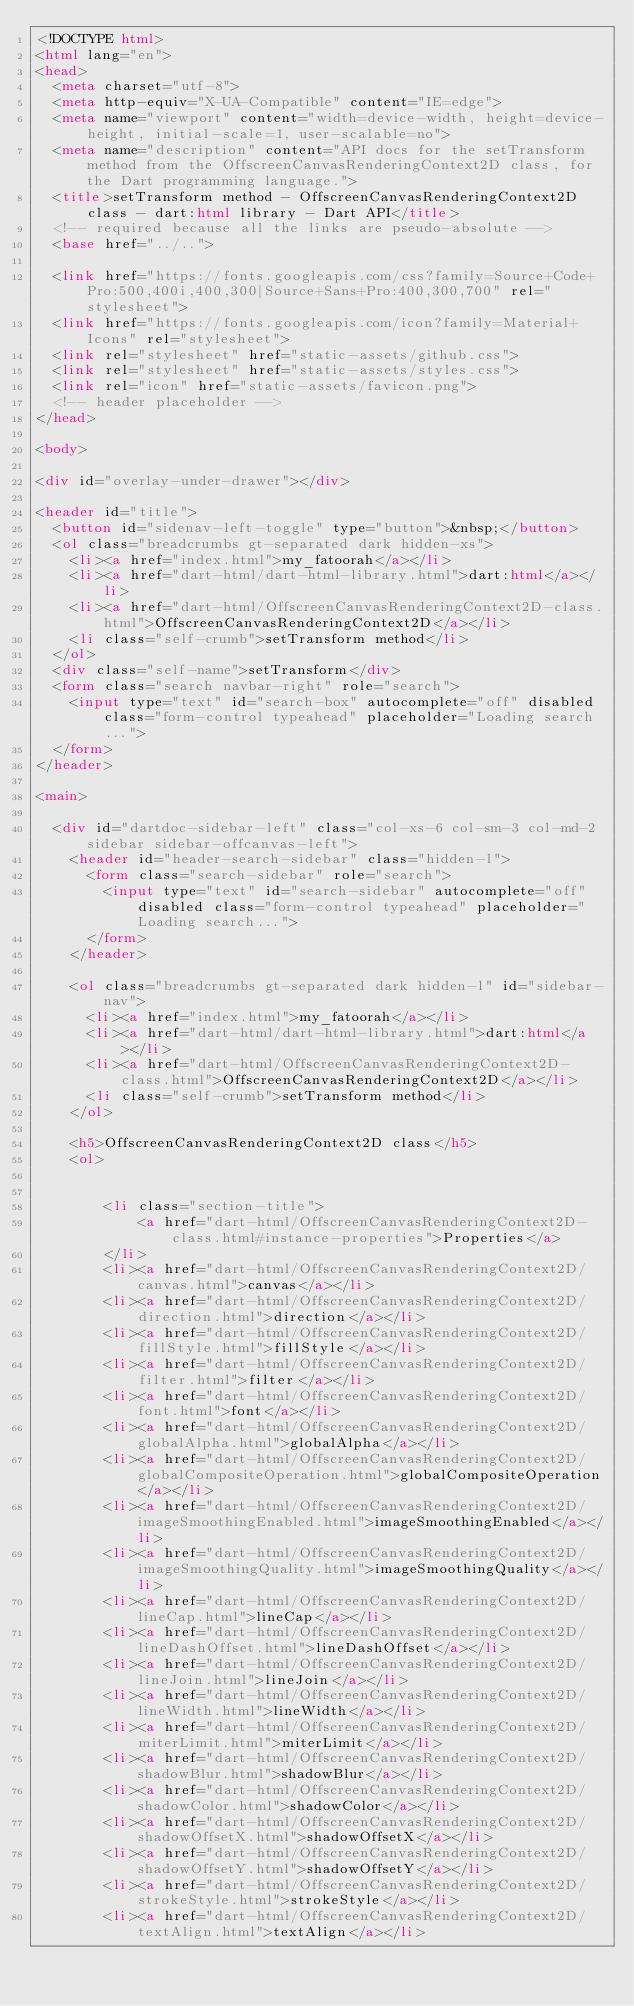Convert code to text. <code><loc_0><loc_0><loc_500><loc_500><_HTML_><!DOCTYPE html>
<html lang="en">
<head>
  <meta charset="utf-8">
  <meta http-equiv="X-UA-Compatible" content="IE=edge">
  <meta name="viewport" content="width=device-width, height=device-height, initial-scale=1, user-scalable=no">
  <meta name="description" content="API docs for the setTransform method from the OffscreenCanvasRenderingContext2D class, for the Dart programming language.">
  <title>setTransform method - OffscreenCanvasRenderingContext2D class - dart:html library - Dart API</title>
  <!-- required because all the links are pseudo-absolute -->
  <base href="../..">

  <link href="https://fonts.googleapis.com/css?family=Source+Code+Pro:500,400i,400,300|Source+Sans+Pro:400,300,700" rel="stylesheet">
  <link href="https://fonts.googleapis.com/icon?family=Material+Icons" rel="stylesheet">
  <link rel="stylesheet" href="static-assets/github.css">
  <link rel="stylesheet" href="static-assets/styles.css">
  <link rel="icon" href="static-assets/favicon.png">
  <!-- header placeholder -->
</head>

<body>

<div id="overlay-under-drawer"></div>

<header id="title">
  <button id="sidenav-left-toggle" type="button">&nbsp;</button>
  <ol class="breadcrumbs gt-separated dark hidden-xs">
    <li><a href="index.html">my_fatoorah</a></li>
    <li><a href="dart-html/dart-html-library.html">dart:html</a></li>
    <li><a href="dart-html/OffscreenCanvasRenderingContext2D-class.html">OffscreenCanvasRenderingContext2D</a></li>
    <li class="self-crumb">setTransform method</li>
  </ol>
  <div class="self-name">setTransform</div>
  <form class="search navbar-right" role="search">
    <input type="text" id="search-box" autocomplete="off" disabled class="form-control typeahead" placeholder="Loading search...">
  </form>
</header>

<main>

  <div id="dartdoc-sidebar-left" class="col-xs-6 col-sm-3 col-md-2 sidebar sidebar-offcanvas-left">
    <header id="header-search-sidebar" class="hidden-l">
      <form class="search-sidebar" role="search">
        <input type="text" id="search-sidebar" autocomplete="off" disabled class="form-control typeahead" placeholder="Loading search...">
      </form>
    </header>
    
    <ol class="breadcrumbs gt-separated dark hidden-l" id="sidebar-nav">
      <li><a href="index.html">my_fatoorah</a></li>
      <li><a href="dart-html/dart-html-library.html">dart:html</a></li>
      <li><a href="dart-html/OffscreenCanvasRenderingContext2D-class.html">OffscreenCanvasRenderingContext2D</a></li>
      <li class="self-crumb">setTransform method</li>
    </ol>
    
    <h5>OffscreenCanvasRenderingContext2D class</h5>
    <ol>
    
    
        <li class="section-title">
            <a href="dart-html/OffscreenCanvasRenderingContext2D-class.html#instance-properties">Properties</a>
        </li>
        <li><a href="dart-html/OffscreenCanvasRenderingContext2D/canvas.html">canvas</a></li>
        <li><a href="dart-html/OffscreenCanvasRenderingContext2D/direction.html">direction</a></li>
        <li><a href="dart-html/OffscreenCanvasRenderingContext2D/fillStyle.html">fillStyle</a></li>
        <li><a href="dart-html/OffscreenCanvasRenderingContext2D/filter.html">filter</a></li>
        <li><a href="dart-html/OffscreenCanvasRenderingContext2D/font.html">font</a></li>
        <li><a href="dart-html/OffscreenCanvasRenderingContext2D/globalAlpha.html">globalAlpha</a></li>
        <li><a href="dart-html/OffscreenCanvasRenderingContext2D/globalCompositeOperation.html">globalCompositeOperation</a></li>
        <li><a href="dart-html/OffscreenCanvasRenderingContext2D/imageSmoothingEnabled.html">imageSmoothingEnabled</a></li>
        <li><a href="dart-html/OffscreenCanvasRenderingContext2D/imageSmoothingQuality.html">imageSmoothingQuality</a></li>
        <li><a href="dart-html/OffscreenCanvasRenderingContext2D/lineCap.html">lineCap</a></li>
        <li><a href="dart-html/OffscreenCanvasRenderingContext2D/lineDashOffset.html">lineDashOffset</a></li>
        <li><a href="dart-html/OffscreenCanvasRenderingContext2D/lineJoin.html">lineJoin</a></li>
        <li><a href="dart-html/OffscreenCanvasRenderingContext2D/lineWidth.html">lineWidth</a></li>
        <li><a href="dart-html/OffscreenCanvasRenderingContext2D/miterLimit.html">miterLimit</a></li>
        <li><a href="dart-html/OffscreenCanvasRenderingContext2D/shadowBlur.html">shadowBlur</a></li>
        <li><a href="dart-html/OffscreenCanvasRenderingContext2D/shadowColor.html">shadowColor</a></li>
        <li><a href="dart-html/OffscreenCanvasRenderingContext2D/shadowOffsetX.html">shadowOffsetX</a></li>
        <li><a href="dart-html/OffscreenCanvasRenderingContext2D/shadowOffsetY.html">shadowOffsetY</a></li>
        <li><a href="dart-html/OffscreenCanvasRenderingContext2D/strokeStyle.html">strokeStyle</a></li>
        <li><a href="dart-html/OffscreenCanvasRenderingContext2D/textAlign.html">textAlign</a></li></code> 